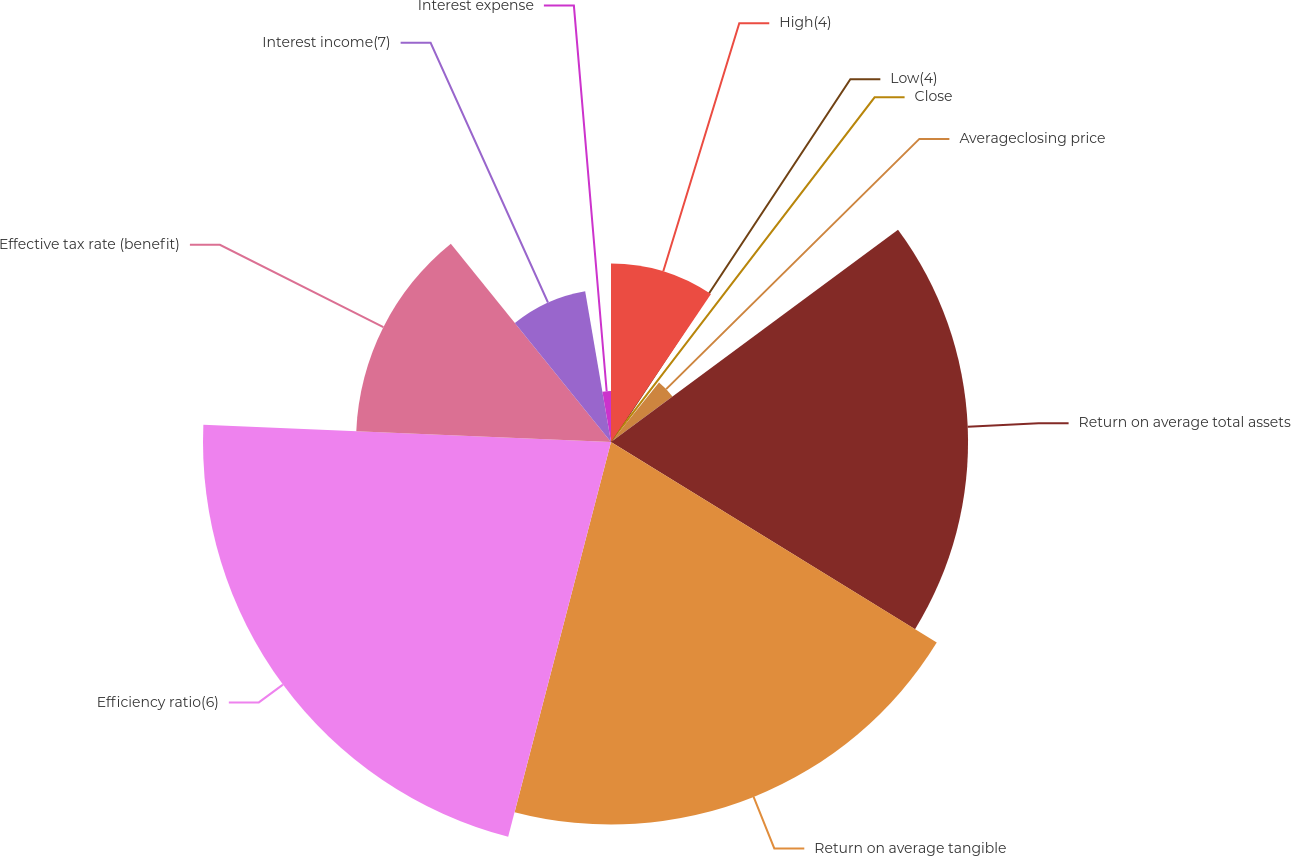Convert chart to OTSL. <chart><loc_0><loc_0><loc_500><loc_500><pie_chart><fcel>High(4)<fcel>Low(4)<fcel>Close<fcel>Averageclosing price<fcel>Return on average total assets<fcel>Return on average tangible<fcel>Efficiency ratio(6)<fcel>Effective tax rate (benefit)<fcel>Interest income(7)<fcel>Interest expense<nl><fcel>9.46%<fcel>0.0%<fcel>1.35%<fcel>4.05%<fcel>18.92%<fcel>20.27%<fcel>21.62%<fcel>13.51%<fcel>8.11%<fcel>2.7%<nl></chart> 